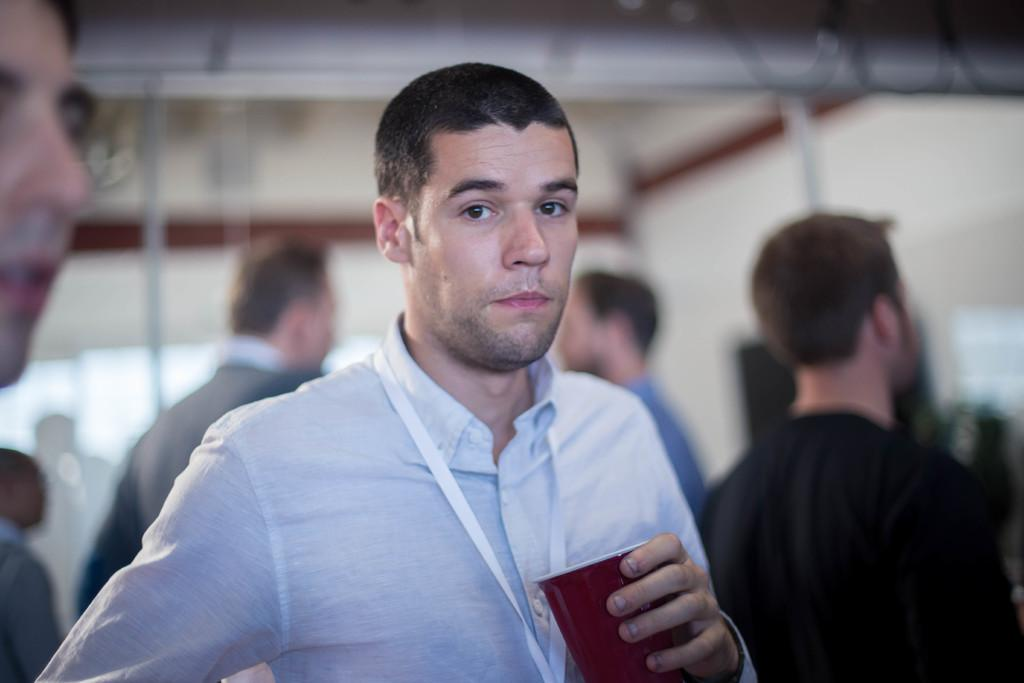Who is the main subject in the image? There is a man in the image. What is the man holding in the image? The man is holding a glass. Where is the man located in the image? The man is in the foreground area of the image. What else can be seen in the image besides the man? There are people in the background of the image. What is the boy writing on the baseball in the image? There is no boy or baseball present in the image. 